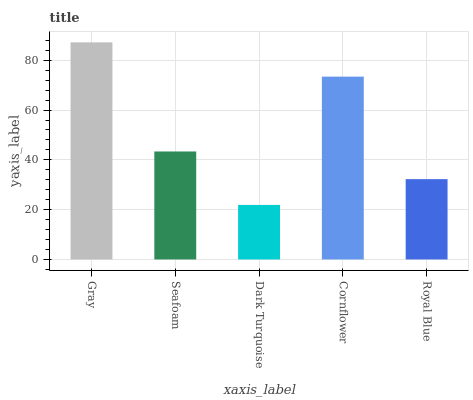Is Dark Turquoise the minimum?
Answer yes or no. Yes. Is Gray the maximum?
Answer yes or no. Yes. Is Seafoam the minimum?
Answer yes or no. No. Is Seafoam the maximum?
Answer yes or no. No. Is Gray greater than Seafoam?
Answer yes or no. Yes. Is Seafoam less than Gray?
Answer yes or no. Yes. Is Seafoam greater than Gray?
Answer yes or no. No. Is Gray less than Seafoam?
Answer yes or no. No. Is Seafoam the high median?
Answer yes or no. Yes. Is Seafoam the low median?
Answer yes or no. Yes. Is Dark Turquoise the high median?
Answer yes or no. No. Is Cornflower the low median?
Answer yes or no. No. 